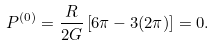<formula> <loc_0><loc_0><loc_500><loc_500>P ^ { ( 0 ) } = \frac { R } { 2 G } \left [ 6 \pi - 3 ( 2 \pi ) \right ] = 0 .</formula> 